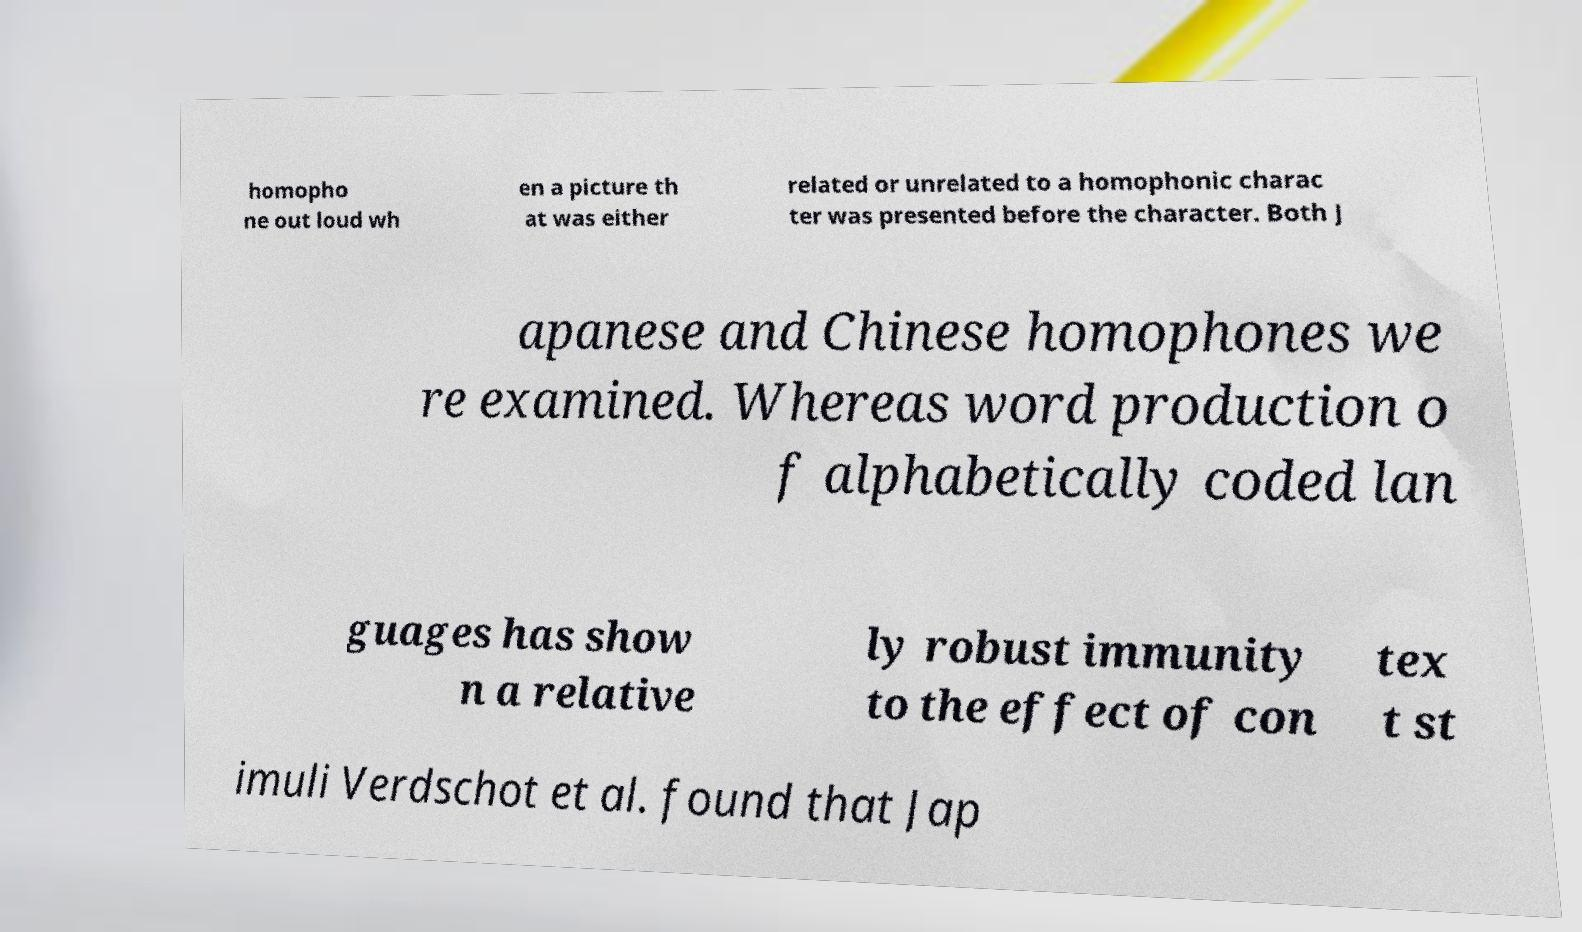Could you assist in decoding the text presented in this image and type it out clearly? homopho ne out loud wh en a picture th at was either related or unrelated to a homophonic charac ter was presented before the character. Both J apanese and Chinese homophones we re examined. Whereas word production o f alphabetically coded lan guages has show n a relative ly robust immunity to the effect of con tex t st imuli Verdschot et al. found that Jap 